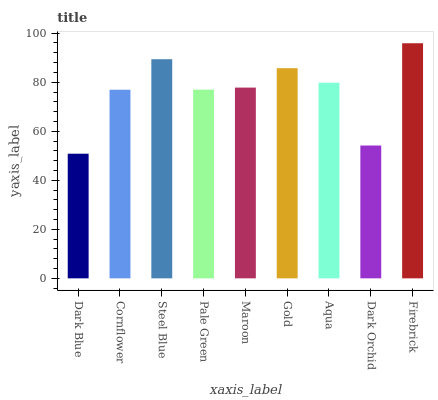Is Dark Blue the minimum?
Answer yes or no. Yes. Is Firebrick the maximum?
Answer yes or no. Yes. Is Cornflower the minimum?
Answer yes or no. No. Is Cornflower the maximum?
Answer yes or no. No. Is Cornflower greater than Dark Blue?
Answer yes or no. Yes. Is Dark Blue less than Cornflower?
Answer yes or no. Yes. Is Dark Blue greater than Cornflower?
Answer yes or no. No. Is Cornflower less than Dark Blue?
Answer yes or no. No. Is Maroon the high median?
Answer yes or no. Yes. Is Maroon the low median?
Answer yes or no. Yes. Is Dark Orchid the high median?
Answer yes or no. No. Is Pale Green the low median?
Answer yes or no. No. 